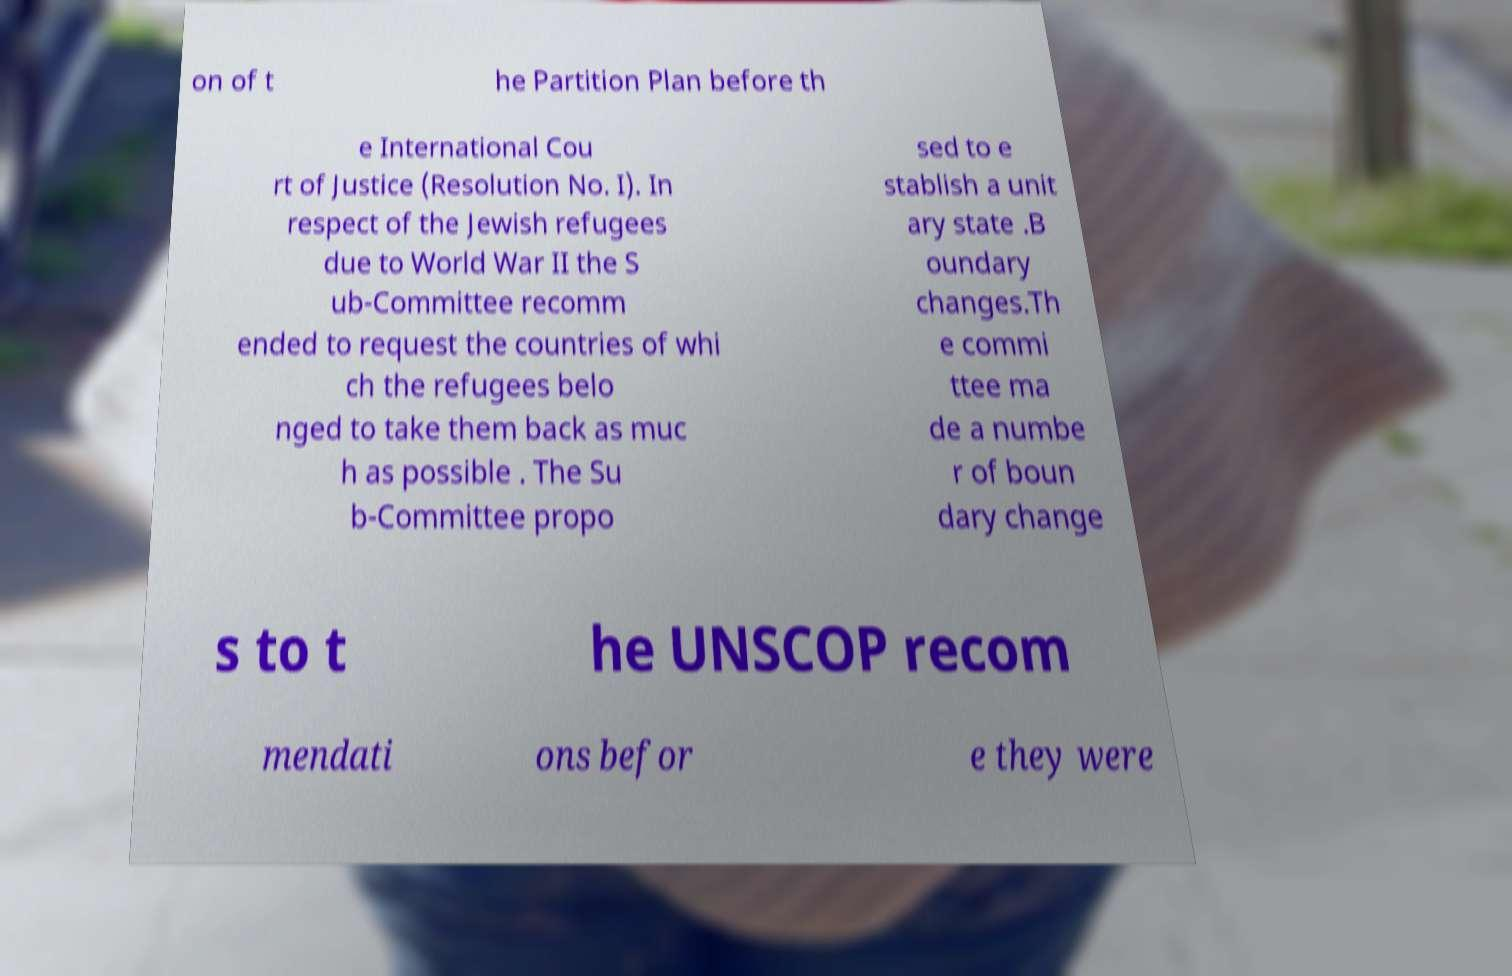Can you accurately transcribe the text from the provided image for me? on of t he Partition Plan before th e International Cou rt of Justice (Resolution No. I). In respect of the Jewish refugees due to World War II the S ub-Committee recomm ended to request the countries of whi ch the refugees belo nged to take them back as muc h as possible . The Su b-Committee propo sed to e stablish a unit ary state .B oundary changes.Th e commi ttee ma de a numbe r of boun dary change s to t he UNSCOP recom mendati ons befor e they were 